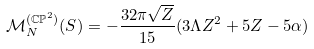Convert formula to latex. <formula><loc_0><loc_0><loc_500><loc_500>\mathcal { M } _ { N } ^ { ( \mathbb { C P } ^ { 2 } ) } ( S ) = - \frac { 3 2 \pi \sqrt { Z } } { 1 5 } ( 3 \Lambda Z ^ { 2 } + 5 Z - 5 \alpha )</formula> 